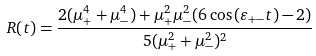Convert formula to latex. <formula><loc_0><loc_0><loc_500><loc_500>R ( t ) = \frac { 2 ( \mu _ { + } ^ { 4 } + \mu _ { - } ^ { 4 } ) + \mu _ { + } ^ { 2 } \mu _ { - } ^ { 2 } ( 6 \cos { ( \varepsilon _ { + - } t ) } - 2 ) } { 5 ( \mu _ { + } ^ { 2 } + \mu _ { - } ^ { 2 } ) ^ { 2 } }</formula> 